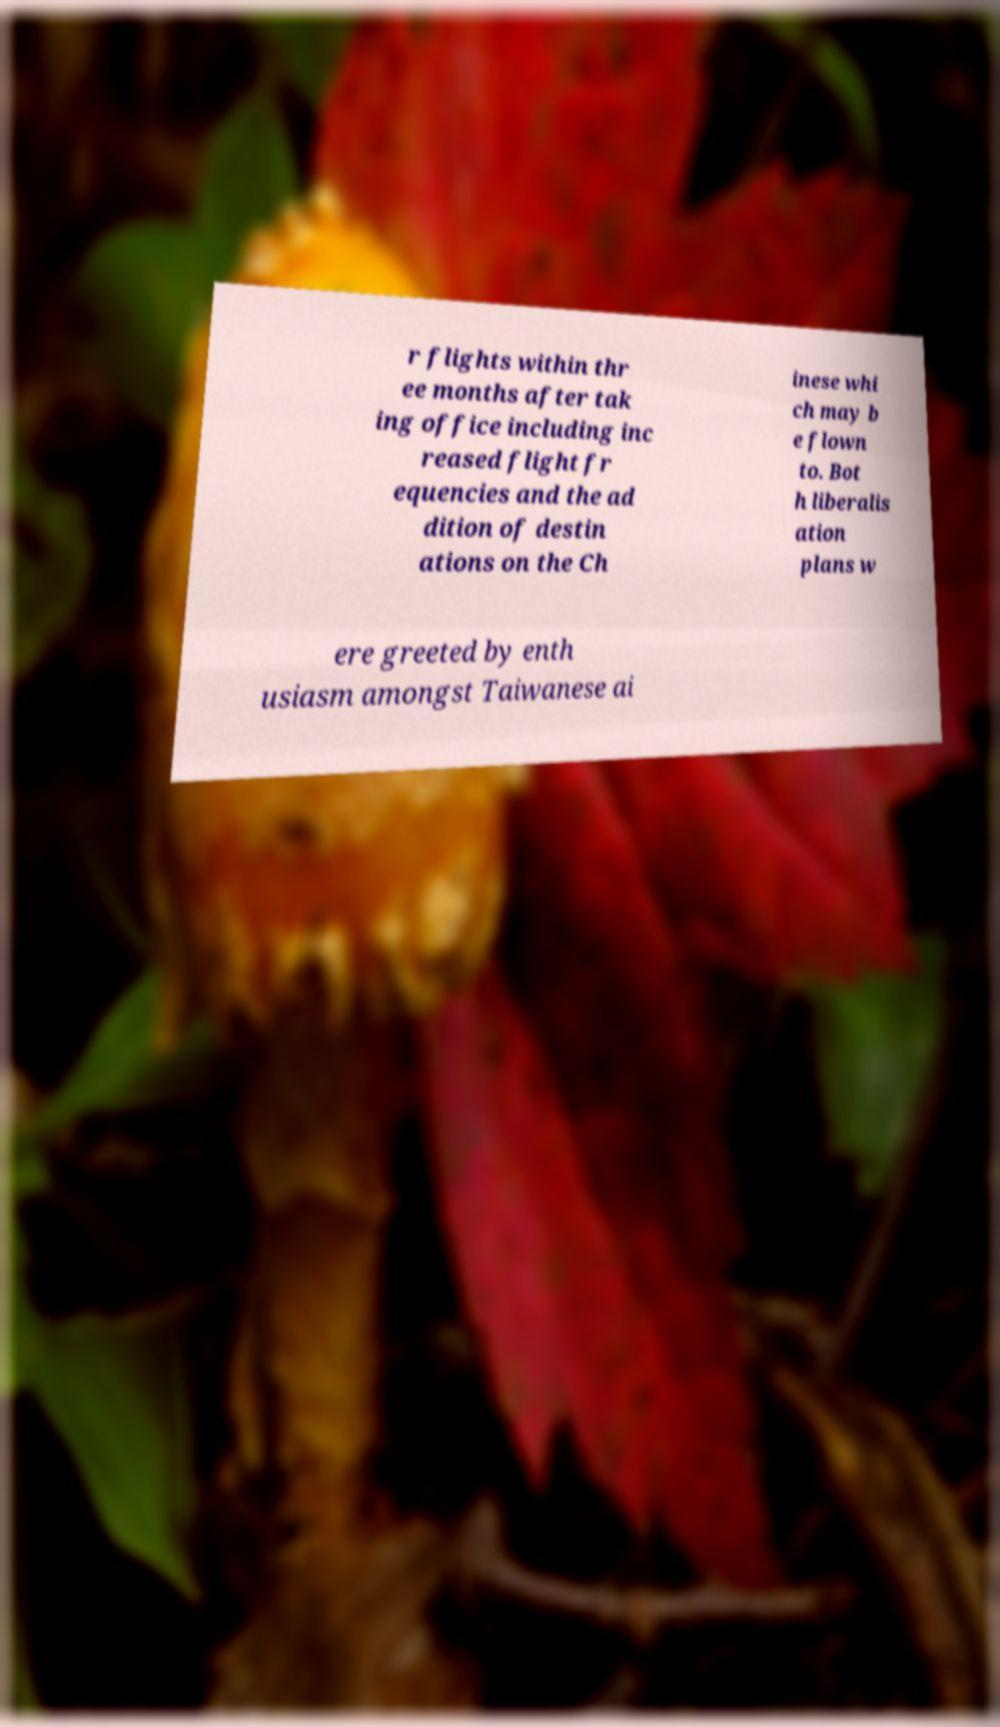I need the written content from this picture converted into text. Can you do that? r flights within thr ee months after tak ing office including inc reased flight fr equencies and the ad dition of destin ations on the Ch inese whi ch may b e flown to. Bot h liberalis ation plans w ere greeted by enth usiasm amongst Taiwanese ai 